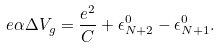Convert formula to latex. <formula><loc_0><loc_0><loc_500><loc_500>e \alpha \Delta V _ { g } = \frac { e ^ { 2 } } { C } + \epsilon ^ { 0 } _ { N + 2 } - \epsilon ^ { 0 } _ { N + 1 } .</formula> 